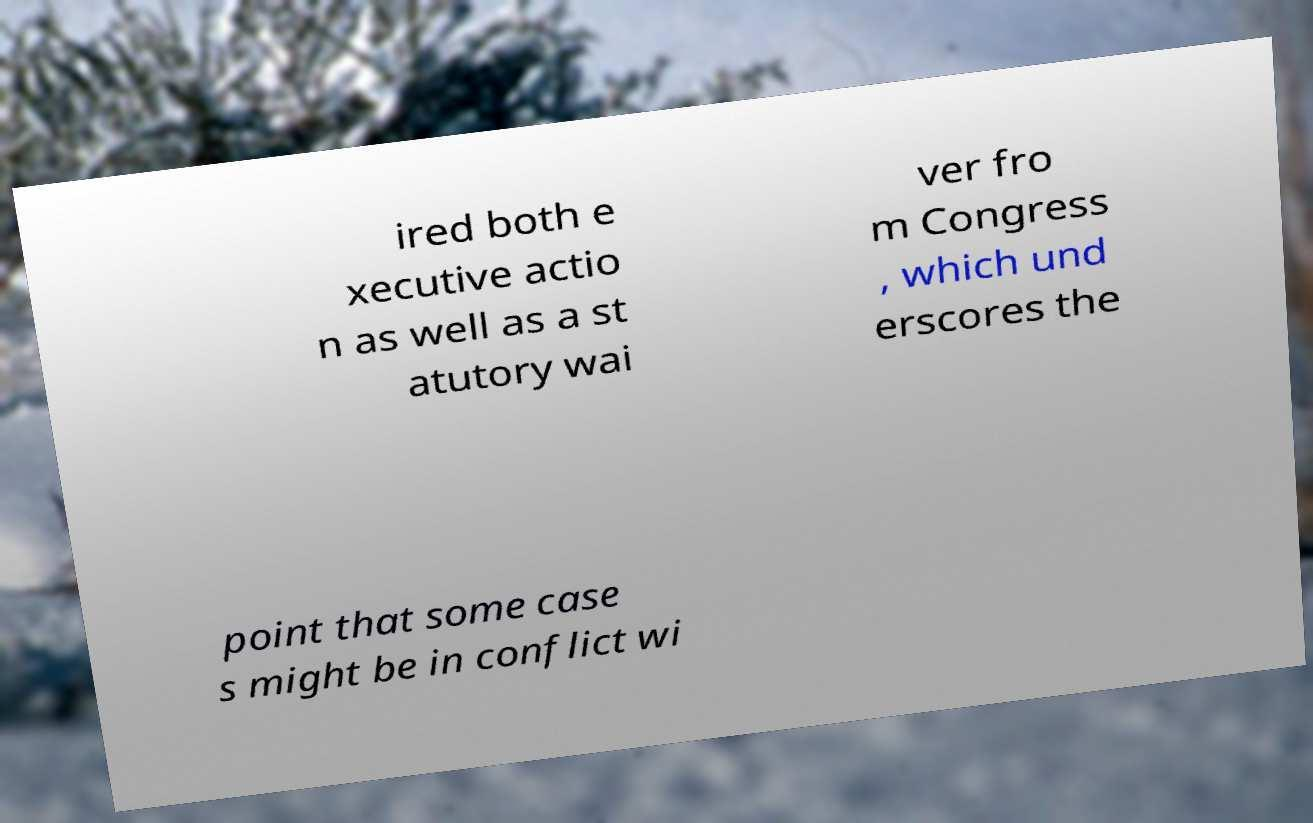For documentation purposes, I need the text within this image transcribed. Could you provide that? ired both e xecutive actio n as well as a st atutory wai ver fro m Congress , which und erscores the point that some case s might be in conflict wi 